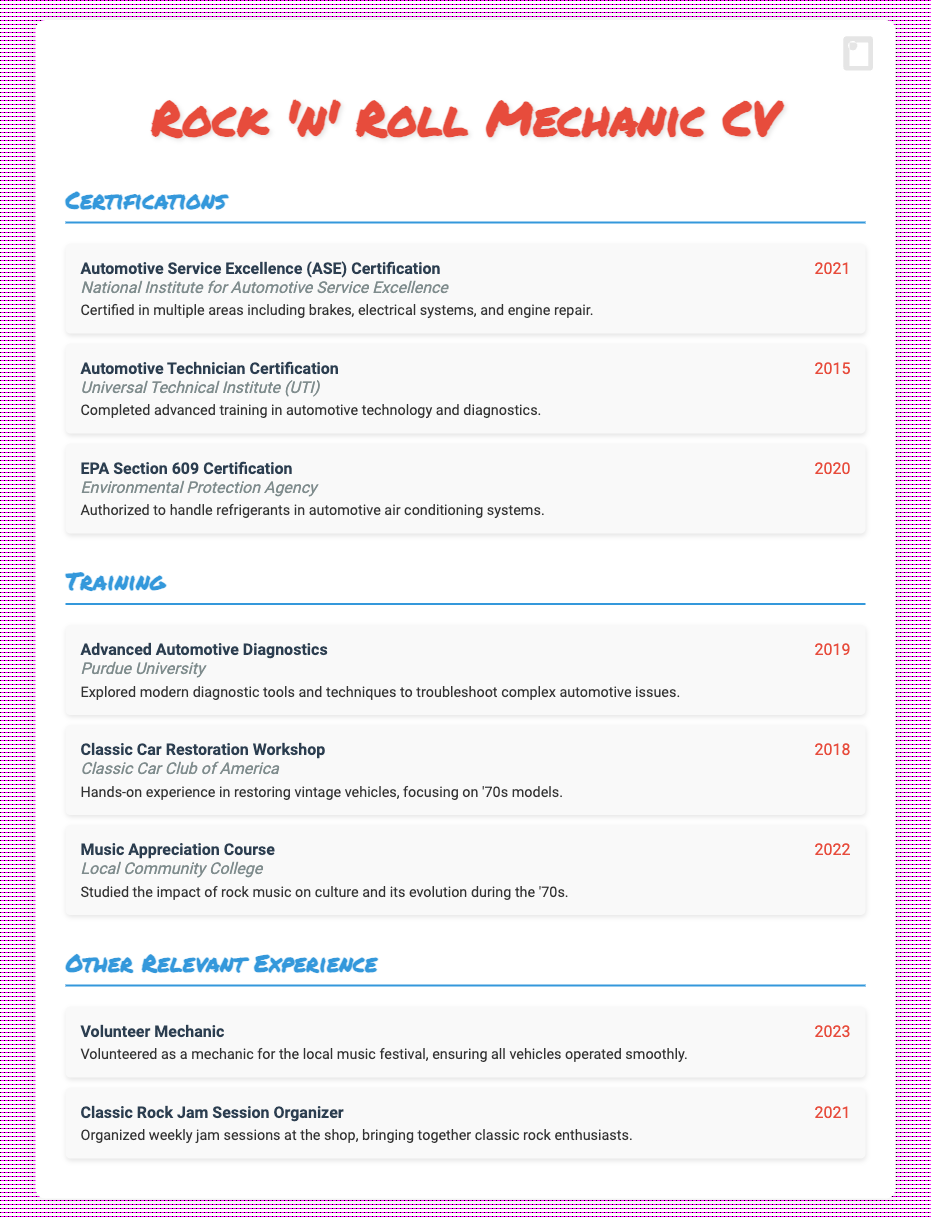what is the first certification listed? The first certification in the list is the Automotive Service Excellence (ASE) Certification.
Answer: Automotive Service Excellence (ASE) Certification who issued the Advanced Automotive Diagnostics training? The training was issued by Purdue University.
Answer: Purdue University what year did the Music Appreciation Course take place? The course took place in 2022.
Answer: 2022 how many certifications are listed in total? There are three certifications listed in the document.
Answer: 3 what is the focus of the Classic Car Restoration Workshop? The workshop focused on restoring vintage vehicles, particularly '70s models.
Answer: restoring vintage vehicles, focusing on '70s models which training includes a study of rock music's impact on culture? The training that includes this study is the Music Appreciation Course.
Answer: Music Appreciation Course who organized weekly jam sessions at the shop? The person who organized the sessions is the Classic Rock Jam Session Organizer.
Answer: Classic Rock Jam Session Organizer when was the EPA Section 609 Certification obtained? The certification was obtained in 2020.
Answer: 2020 